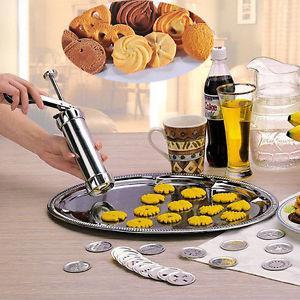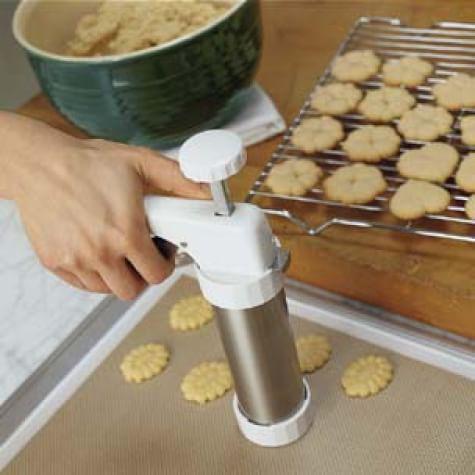The first image is the image on the left, the second image is the image on the right. Evaluate the accuracy of this statement regarding the images: "Each image includes raw cookie dough, and at least one image includes raw cookie dough in a round bowl and a spoon with cookie dough on it.". Is it true? Answer yes or no. No. The first image is the image on the left, the second image is the image on the right. For the images displayed, is the sentence "There is at least one human hand visible here." factually correct? Answer yes or no. Yes. 